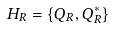<formula> <loc_0><loc_0><loc_500><loc_500>H _ { R } = \{ Q _ { R } , Q ^ { * } _ { R } \}</formula> 